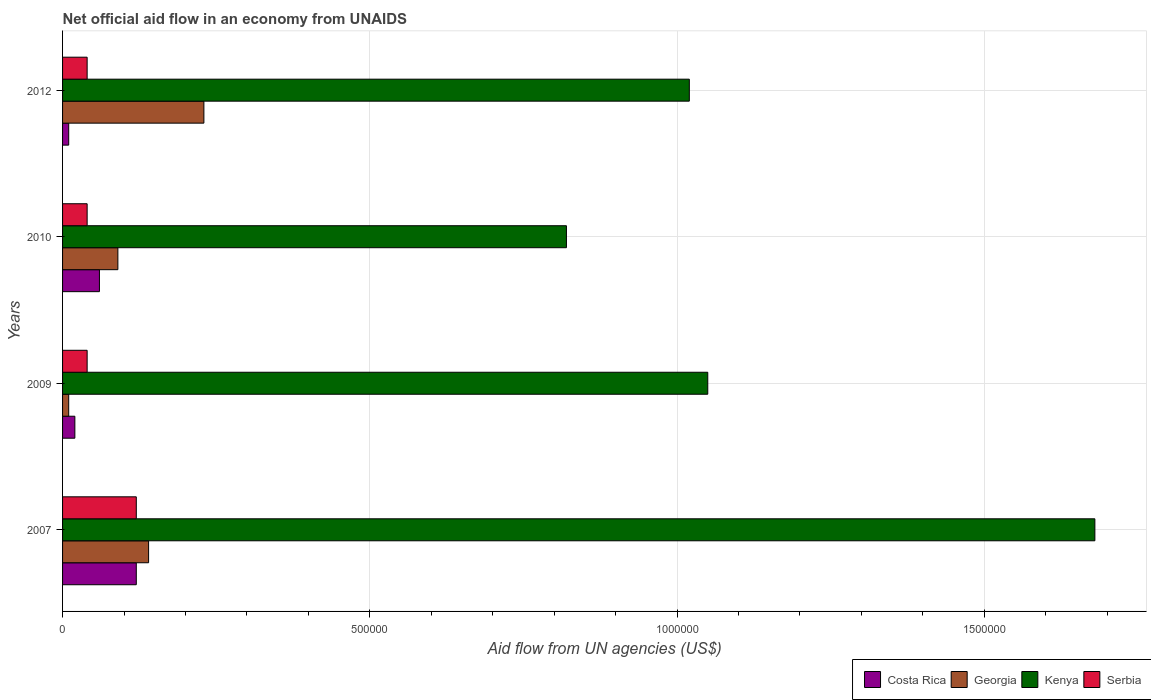How many groups of bars are there?
Provide a short and direct response. 4. Across all years, what is the maximum net official aid flow in Kenya?
Provide a short and direct response. 1.68e+06. In which year was the net official aid flow in Serbia maximum?
Keep it short and to the point. 2007. In which year was the net official aid flow in Georgia minimum?
Your answer should be compact. 2009. What is the difference between the net official aid flow in Serbia in 2007 and that in 2012?
Ensure brevity in your answer.  8.00e+04. What is the average net official aid flow in Kenya per year?
Give a very brief answer. 1.14e+06. In the year 2009, what is the difference between the net official aid flow in Serbia and net official aid flow in Kenya?
Your answer should be compact. -1.01e+06. In how many years, is the net official aid flow in Georgia greater than 1400000 US$?
Provide a succinct answer. 0. What is the ratio of the net official aid flow in Costa Rica in 2010 to that in 2012?
Offer a terse response. 6. What is the difference between the highest and the second highest net official aid flow in Serbia?
Ensure brevity in your answer.  8.00e+04. What is the difference between the highest and the lowest net official aid flow in Georgia?
Ensure brevity in your answer.  2.20e+05. Is it the case that in every year, the sum of the net official aid flow in Kenya and net official aid flow in Costa Rica is greater than the sum of net official aid flow in Georgia and net official aid flow in Serbia?
Your answer should be very brief. No. What does the 2nd bar from the top in 2007 represents?
Provide a succinct answer. Kenya. What does the 4th bar from the bottom in 2007 represents?
Your answer should be very brief. Serbia. How many years are there in the graph?
Provide a short and direct response. 4. Are the values on the major ticks of X-axis written in scientific E-notation?
Ensure brevity in your answer.  No. Does the graph contain any zero values?
Offer a terse response. No. How are the legend labels stacked?
Give a very brief answer. Horizontal. What is the title of the graph?
Offer a terse response. Net official aid flow in an economy from UNAIDS. Does "China" appear as one of the legend labels in the graph?
Keep it short and to the point. No. What is the label or title of the X-axis?
Provide a succinct answer. Aid flow from UN agencies (US$). What is the label or title of the Y-axis?
Your answer should be very brief. Years. What is the Aid flow from UN agencies (US$) of Kenya in 2007?
Provide a short and direct response. 1.68e+06. What is the Aid flow from UN agencies (US$) in Costa Rica in 2009?
Your response must be concise. 2.00e+04. What is the Aid flow from UN agencies (US$) in Kenya in 2009?
Your answer should be very brief. 1.05e+06. What is the Aid flow from UN agencies (US$) of Costa Rica in 2010?
Make the answer very short. 6.00e+04. What is the Aid flow from UN agencies (US$) in Kenya in 2010?
Offer a terse response. 8.20e+05. What is the Aid flow from UN agencies (US$) in Serbia in 2010?
Keep it short and to the point. 4.00e+04. What is the Aid flow from UN agencies (US$) in Georgia in 2012?
Provide a succinct answer. 2.30e+05. What is the Aid flow from UN agencies (US$) of Kenya in 2012?
Give a very brief answer. 1.02e+06. What is the Aid flow from UN agencies (US$) of Serbia in 2012?
Your response must be concise. 4.00e+04. Across all years, what is the maximum Aid flow from UN agencies (US$) of Costa Rica?
Keep it short and to the point. 1.20e+05. Across all years, what is the maximum Aid flow from UN agencies (US$) in Georgia?
Provide a succinct answer. 2.30e+05. Across all years, what is the maximum Aid flow from UN agencies (US$) of Kenya?
Offer a very short reply. 1.68e+06. Across all years, what is the maximum Aid flow from UN agencies (US$) in Serbia?
Offer a terse response. 1.20e+05. Across all years, what is the minimum Aid flow from UN agencies (US$) in Costa Rica?
Ensure brevity in your answer.  10000. Across all years, what is the minimum Aid flow from UN agencies (US$) in Georgia?
Provide a short and direct response. 10000. Across all years, what is the minimum Aid flow from UN agencies (US$) in Kenya?
Your response must be concise. 8.20e+05. What is the total Aid flow from UN agencies (US$) of Costa Rica in the graph?
Ensure brevity in your answer.  2.10e+05. What is the total Aid flow from UN agencies (US$) of Georgia in the graph?
Offer a terse response. 4.70e+05. What is the total Aid flow from UN agencies (US$) in Kenya in the graph?
Your answer should be compact. 4.57e+06. What is the total Aid flow from UN agencies (US$) of Serbia in the graph?
Your response must be concise. 2.40e+05. What is the difference between the Aid flow from UN agencies (US$) in Georgia in 2007 and that in 2009?
Your answer should be compact. 1.30e+05. What is the difference between the Aid flow from UN agencies (US$) of Kenya in 2007 and that in 2009?
Offer a very short reply. 6.30e+05. What is the difference between the Aid flow from UN agencies (US$) in Serbia in 2007 and that in 2009?
Keep it short and to the point. 8.00e+04. What is the difference between the Aid flow from UN agencies (US$) of Georgia in 2007 and that in 2010?
Your answer should be compact. 5.00e+04. What is the difference between the Aid flow from UN agencies (US$) in Kenya in 2007 and that in 2010?
Your response must be concise. 8.60e+05. What is the difference between the Aid flow from UN agencies (US$) of Costa Rica in 2007 and that in 2012?
Your response must be concise. 1.10e+05. What is the difference between the Aid flow from UN agencies (US$) in Kenya in 2007 and that in 2012?
Offer a terse response. 6.60e+05. What is the difference between the Aid flow from UN agencies (US$) of Serbia in 2007 and that in 2012?
Your response must be concise. 8.00e+04. What is the difference between the Aid flow from UN agencies (US$) in Costa Rica in 2009 and that in 2010?
Provide a short and direct response. -4.00e+04. What is the difference between the Aid flow from UN agencies (US$) of Serbia in 2009 and that in 2010?
Offer a very short reply. 0. What is the difference between the Aid flow from UN agencies (US$) of Georgia in 2009 and that in 2012?
Provide a succinct answer. -2.20e+05. What is the difference between the Aid flow from UN agencies (US$) in Serbia in 2009 and that in 2012?
Offer a very short reply. 0. What is the difference between the Aid flow from UN agencies (US$) in Serbia in 2010 and that in 2012?
Make the answer very short. 0. What is the difference between the Aid flow from UN agencies (US$) in Costa Rica in 2007 and the Aid flow from UN agencies (US$) in Georgia in 2009?
Make the answer very short. 1.10e+05. What is the difference between the Aid flow from UN agencies (US$) of Costa Rica in 2007 and the Aid flow from UN agencies (US$) of Kenya in 2009?
Your response must be concise. -9.30e+05. What is the difference between the Aid flow from UN agencies (US$) in Georgia in 2007 and the Aid flow from UN agencies (US$) in Kenya in 2009?
Offer a very short reply. -9.10e+05. What is the difference between the Aid flow from UN agencies (US$) in Kenya in 2007 and the Aid flow from UN agencies (US$) in Serbia in 2009?
Provide a succinct answer. 1.64e+06. What is the difference between the Aid flow from UN agencies (US$) in Costa Rica in 2007 and the Aid flow from UN agencies (US$) in Georgia in 2010?
Provide a succinct answer. 3.00e+04. What is the difference between the Aid flow from UN agencies (US$) of Costa Rica in 2007 and the Aid flow from UN agencies (US$) of Kenya in 2010?
Keep it short and to the point. -7.00e+05. What is the difference between the Aid flow from UN agencies (US$) in Georgia in 2007 and the Aid flow from UN agencies (US$) in Kenya in 2010?
Offer a terse response. -6.80e+05. What is the difference between the Aid flow from UN agencies (US$) in Kenya in 2007 and the Aid flow from UN agencies (US$) in Serbia in 2010?
Provide a succinct answer. 1.64e+06. What is the difference between the Aid flow from UN agencies (US$) in Costa Rica in 2007 and the Aid flow from UN agencies (US$) in Kenya in 2012?
Ensure brevity in your answer.  -9.00e+05. What is the difference between the Aid flow from UN agencies (US$) of Costa Rica in 2007 and the Aid flow from UN agencies (US$) of Serbia in 2012?
Provide a short and direct response. 8.00e+04. What is the difference between the Aid flow from UN agencies (US$) of Georgia in 2007 and the Aid flow from UN agencies (US$) of Kenya in 2012?
Provide a short and direct response. -8.80e+05. What is the difference between the Aid flow from UN agencies (US$) in Georgia in 2007 and the Aid flow from UN agencies (US$) in Serbia in 2012?
Make the answer very short. 1.00e+05. What is the difference between the Aid flow from UN agencies (US$) of Kenya in 2007 and the Aid flow from UN agencies (US$) of Serbia in 2012?
Ensure brevity in your answer.  1.64e+06. What is the difference between the Aid flow from UN agencies (US$) in Costa Rica in 2009 and the Aid flow from UN agencies (US$) in Georgia in 2010?
Your answer should be very brief. -7.00e+04. What is the difference between the Aid flow from UN agencies (US$) in Costa Rica in 2009 and the Aid flow from UN agencies (US$) in Kenya in 2010?
Ensure brevity in your answer.  -8.00e+05. What is the difference between the Aid flow from UN agencies (US$) in Costa Rica in 2009 and the Aid flow from UN agencies (US$) in Serbia in 2010?
Your answer should be compact. -2.00e+04. What is the difference between the Aid flow from UN agencies (US$) of Georgia in 2009 and the Aid flow from UN agencies (US$) of Kenya in 2010?
Give a very brief answer. -8.10e+05. What is the difference between the Aid flow from UN agencies (US$) of Georgia in 2009 and the Aid flow from UN agencies (US$) of Serbia in 2010?
Provide a short and direct response. -3.00e+04. What is the difference between the Aid flow from UN agencies (US$) of Kenya in 2009 and the Aid flow from UN agencies (US$) of Serbia in 2010?
Offer a terse response. 1.01e+06. What is the difference between the Aid flow from UN agencies (US$) of Costa Rica in 2009 and the Aid flow from UN agencies (US$) of Georgia in 2012?
Keep it short and to the point. -2.10e+05. What is the difference between the Aid flow from UN agencies (US$) of Georgia in 2009 and the Aid flow from UN agencies (US$) of Kenya in 2012?
Your response must be concise. -1.01e+06. What is the difference between the Aid flow from UN agencies (US$) of Kenya in 2009 and the Aid flow from UN agencies (US$) of Serbia in 2012?
Your answer should be very brief. 1.01e+06. What is the difference between the Aid flow from UN agencies (US$) of Costa Rica in 2010 and the Aid flow from UN agencies (US$) of Georgia in 2012?
Ensure brevity in your answer.  -1.70e+05. What is the difference between the Aid flow from UN agencies (US$) in Costa Rica in 2010 and the Aid flow from UN agencies (US$) in Kenya in 2012?
Your answer should be very brief. -9.60e+05. What is the difference between the Aid flow from UN agencies (US$) of Georgia in 2010 and the Aid flow from UN agencies (US$) of Kenya in 2012?
Give a very brief answer. -9.30e+05. What is the difference between the Aid flow from UN agencies (US$) in Kenya in 2010 and the Aid flow from UN agencies (US$) in Serbia in 2012?
Your answer should be compact. 7.80e+05. What is the average Aid flow from UN agencies (US$) of Costa Rica per year?
Provide a succinct answer. 5.25e+04. What is the average Aid flow from UN agencies (US$) in Georgia per year?
Keep it short and to the point. 1.18e+05. What is the average Aid flow from UN agencies (US$) in Kenya per year?
Give a very brief answer. 1.14e+06. In the year 2007, what is the difference between the Aid flow from UN agencies (US$) of Costa Rica and Aid flow from UN agencies (US$) of Georgia?
Offer a very short reply. -2.00e+04. In the year 2007, what is the difference between the Aid flow from UN agencies (US$) of Costa Rica and Aid flow from UN agencies (US$) of Kenya?
Your answer should be very brief. -1.56e+06. In the year 2007, what is the difference between the Aid flow from UN agencies (US$) of Georgia and Aid flow from UN agencies (US$) of Kenya?
Provide a short and direct response. -1.54e+06. In the year 2007, what is the difference between the Aid flow from UN agencies (US$) in Georgia and Aid flow from UN agencies (US$) in Serbia?
Ensure brevity in your answer.  2.00e+04. In the year 2007, what is the difference between the Aid flow from UN agencies (US$) in Kenya and Aid flow from UN agencies (US$) in Serbia?
Ensure brevity in your answer.  1.56e+06. In the year 2009, what is the difference between the Aid flow from UN agencies (US$) of Costa Rica and Aid flow from UN agencies (US$) of Georgia?
Provide a succinct answer. 10000. In the year 2009, what is the difference between the Aid flow from UN agencies (US$) of Costa Rica and Aid flow from UN agencies (US$) of Kenya?
Make the answer very short. -1.03e+06. In the year 2009, what is the difference between the Aid flow from UN agencies (US$) in Costa Rica and Aid flow from UN agencies (US$) in Serbia?
Make the answer very short. -2.00e+04. In the year 2009, what is the difference between the Aid flow from UN agencies (US$) of Georgia and Aid flow from UN agencies (US$) of Kenya?
Provide a short and direct response. -1.04e+06. In the year 2009, what is the difference between the Aid flow from UN agencies (US$) in Georgia and Aid flow from UN agencies (US$) in Serbia?
Your answer should be compact. -3.00e+04. In the year 2009, what is the difference between the Aid flow from UN agencies (US$) in Kenya and Aid flow from UN agencies (US$) in Serbia?
Provide a succinct answer. 1.01e+06. In the year 2010, what is the difference between the Aid flow from UN agencies (US$) of Costa Rica and Aid flow from UN agencies (US$) of Kenya?
Ensure brevity in your answer.  -7.60e+05. In the year 2010, what is the difference between the Aid flow from UN agencies (US$) in Costa Rica and Aid flow from UN agencies (US$) in Serbia?
Make the answer very short. 2.00e+04. In the year 2010, what is the difference between the Aid flow from UN agencies (US$) in Georgia and Aid flow from UN agencies (US$) in Kenya?
Ensure brevity in your answer.  -7.30e+05. In the year 2010, what is the difference between the Aid flow from UN agencies (US$) of Georgia and Aid flow from UN agencies (US$) of Serbia?
Your answer should be compact. 5.00e+04. In the year 2010, what is the difference between the Aid flow from UN agencies (US$) of Kenya and Aid flow from UN agencies (US$) of Serbia?
Your answer should be compact. 7.80e+05. In the year 2012, what is the difference between the Aid flow from UN agencies (US$) of Costa Rica and Aid flow from UN agencies (US$) of Kenya?
Your response must be concise. -1.01e+06. In the year 2012, what is the difference between the Aid flow from UN agencies (US$) of Georgia and Aid flow from UN agencies (US$) of Kenya?
Offer a terse response. -7.90e+05. In the year 2012, what is the difference between the Aid flow from UN agencies (US$) of Georgia and Aid flow from UN agencies (US$) of Serbia?
Your answer should be compact. 1.90e+05. In the year 2012, what is the difference between the Aid flow from UN agencies (US$) of Kenya and Aid flow from UN agencies (US$) of Serbia?
Keep it short and to the point. 9.80e+05. What is the ratio of the Aid flow from UN agencies (US$) of Georgia in 2007 to that in 2010?
Give a very brief answer. 1.56. What is the ratio of the Aid flow from UN agencies (US$) of Kenya in 2007 to that in 2010?
Keep it short and to the point. 2.05. What is the ratio of the Aid flow from UN agencies (US$) in Serbia in 2007 to that in 2010?
Provide a short and direct response. 3. What is the ratio of the Aid flow from UN agencies (US$) of Costa Rica in 2007 to that in 2012?
Your answer should be very brief. 12. What is the ratio of the Aid flow from UN agencies (US$) in Georgia in 2007 to that in 2012?
Your answer should be very brief. 0.61. What is the ratio of the Aid flow from UN agencies (US$) of Kenya in 2007 to that in 2012?
Offer a terse response. 1.65. What is the ratio of the Aid flow from UN agencies (US$) of Costa Rica in 2009 to that in 2010?
Give a very brief answer. 0.33. What is the ratio of the Aid flow from UN agencies (US$) in Georgia in 2009 to that in 2010?
Keep it short and to the point. 0.11. What is the ratio of the Aid flow from UN agencies (US$) in Kenya in 2009 to that in 2010?
Offer a terse response. 1.28. What is the ratio of the Aid flow from UN agencies (US$) of Georgia in 2009 to that in 2012?
Make the answer very short. 0.04. What is the ratio of the Aid flow from UN agencies (US$) in Kenya in 2009 to that in 2012?
Your answer should be compact. 1.03. What is the ratio of the Aid flow from UN agencies (US$) in Serbia in 2009 to that in 2012?
Offer a terse response. 1. What is the ratio of the Aid flow from UN agencies (US$) in Costa Rica in 2010 to that in 2012?
Your response must be concise. 6. What is the ratio of the Aid flow from UN agencies (US$) of Georgia in 2010 to that in 2012?
Give a very brief answer. 0.39. What is the ratio of the Aid flow from UN agencies (US$) in Kenya in 2010 to that in 2012?
Ensure brevity in your answer.  0.8. What is the difference between the highest and the second highest Aid flow from UN agencies (US$) in Georgia?
Provide a succinct answer. 9.00e+04. What is the difference between the highest and the second highest Aid flow from UN agencies (US$) in Kenya?
Make the answer very short. 6.30e+05. What is the difference between the highest and the lowest Aid flow from UN agencies (US$) in Costa Rica?
Your answer should be compact. 1.10e+05. What is the difference between the highest and the lowest Aid flow from UN agencies (US$) of Kenya?
Ensure brevity in your answer.  8.60e+05. What is the difference between the highest and the lowest Aid flow from UN agencies (US$) of Serbia?
Give a very brief answer. 8.00e+04. 